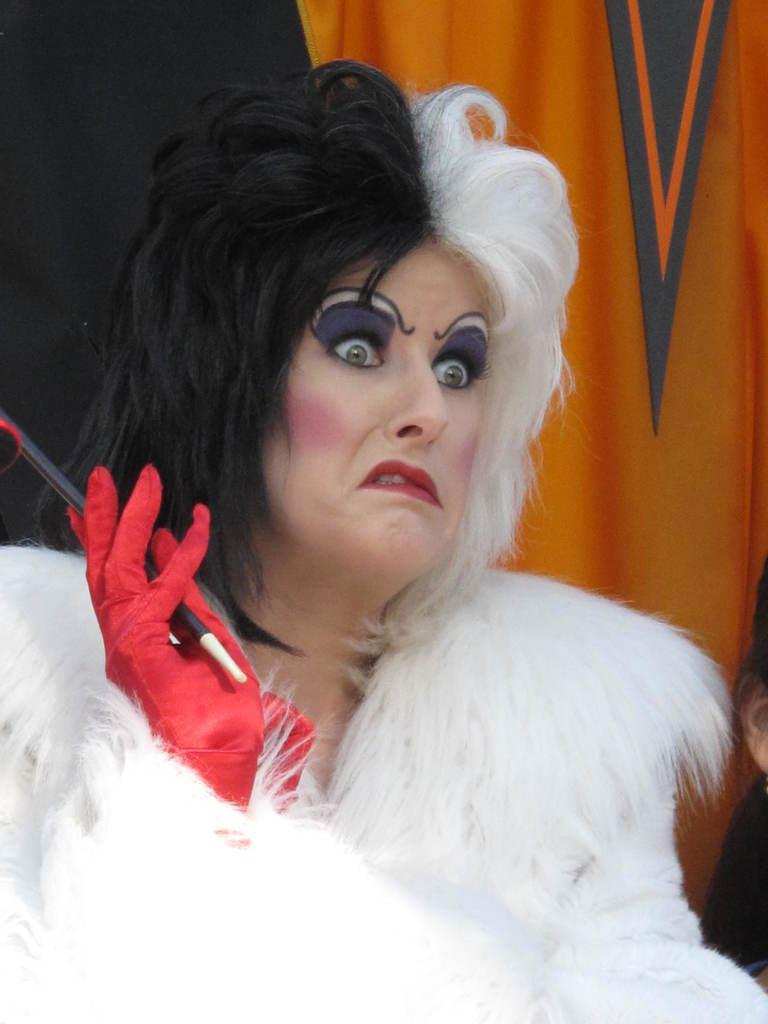Who is present in the image? There is a woman in the image. What can be seen in the background of the image? There is a cloth in the background of the image. What type of shop can be seen in the image? There is no shop present in the image; it only features a woman and a cloth in the background. What is the woman doing to wash in the image? There is no indication of the woman washing anything in the image, as it only shows her presence and the cloth in the background. 